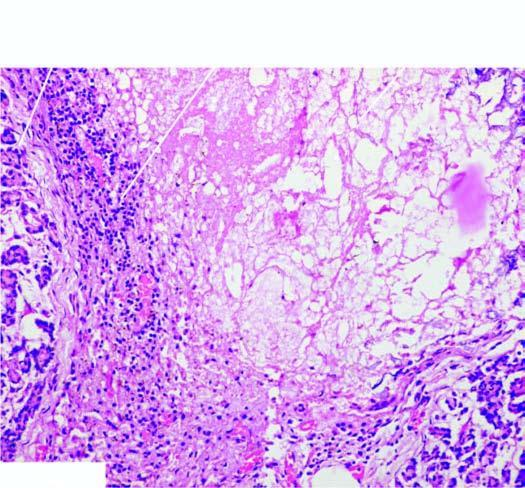s there destruction of acinar tissue and presence of dystrophic calcification?
Answer the question using a single word or phrase. Yes 